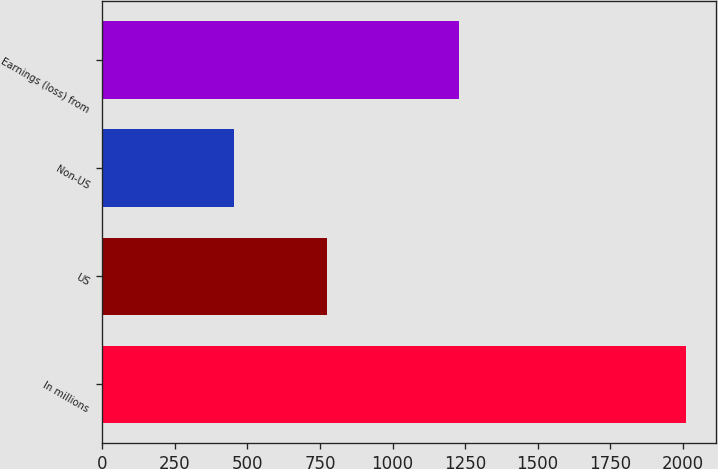Convert chart. <chart><loc_0><loc_0><loc_500><loc_500><bar_chart><fcel>In millions<fcel>US<fcel>Non-US<fcel>Earnings (loss) from<nl><fcel>2013<fcel>775<fcel>453<fcel>1228<nl></chart> 